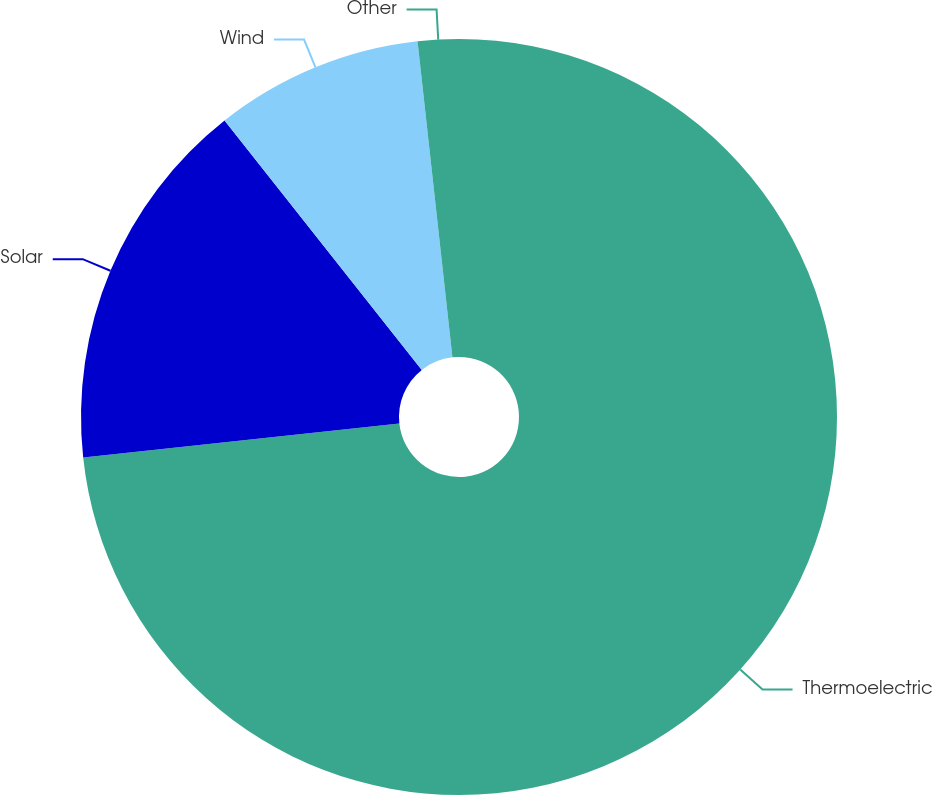<chart> <loc_0><loc_0><loc_500><loc_500><pie_chart><fcel>Thermoelectric<fcel>Solar<fcel>Wind<fcel>Other<nl><fcel>73.3%<fcel>16.06%<fcel>8.9%<fcel>1.75%<nl></chart> 